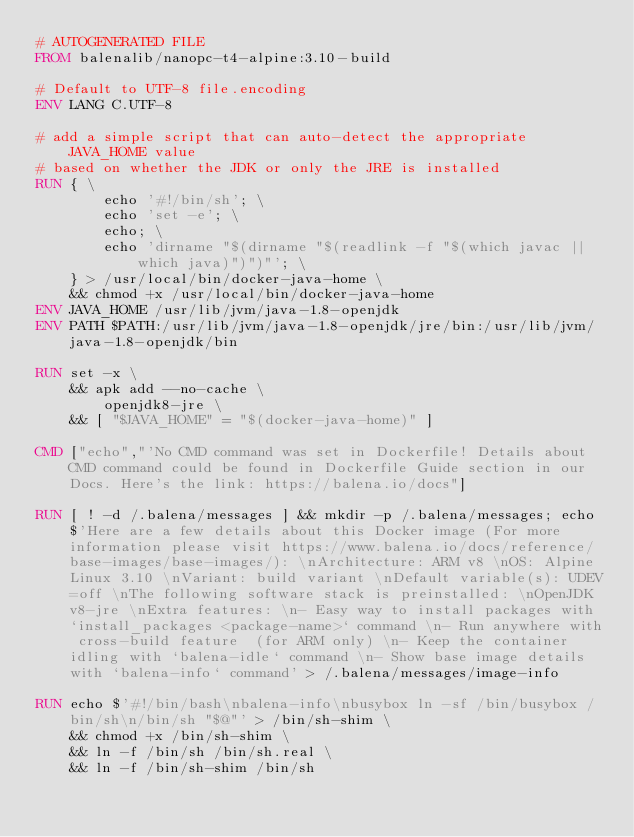Convert code to text. <code><loc_0><loc_0><loc_500><loc_500><_Dockerfile_># AUTOGENERATED FILE
FROM balenalib/nanopc-t4-alpine:3.10-build

# Default to UTF-8 file.encoding
ENV LANG C.UTF-8

# add a simple script that can auto-detect the appropriate JAVA_HOME value
# based on whether the JDK or only the JRE is installed
RUN { \
		echo '#!/bin/sh'; \
		echo 'set -e'; \
		echo; \
		echo 'dirname "$(dirname "$(readlink -f "$(which javac || which java)")")"'; \
	} > /usr/local/bin/docker-java-home \
	&& chmod +x /usr/local/bin/docker-java-home
ENV JAVA_HOME /usr/lib/jvm/java-1.8-openjdk
ENV PATH $PATH:/usr/lib/jvm/java-1.8-openjdk/jre/bin:/usr/lib/jvm/java-1.8-openjdk/bin

RUN set -x \
	&& apk add --no-cache \
		openjdk8-jre \
	&& [ "$JAVA_HOME" = "$(docker-java-home)" ]

CMD ["echo","'No CMD command was set in Dockerfile! Details about CMD command could be found in Dockerfile Guide section in our Docs. Here's the link: https://balena.io/docs"]

RUN [ ! -d /.balena/messages ] && mkdir -p /.balena/messages; echo $'Here are a few details about this Docker image (For more information please visit https://www.balena.io/docs/reference/base-images/base-images/): \nArchitecture: ARM v8 \nOS: Alpine Linux 3.10 \nVariant: build variant \nDefault variable(s): UDEV=off \nThe following software stack is preinstalled: \nOpenJDK v8-jre \nExtra features: \n- Easy way to install packages with `install_packages <package-name>` command \n- Run anywhere with cross-build feature  (for ARM only) \n- Keep the container idling with `balena-idle` command \n- Show base image details with `balena-info` command' > /.balena/messages/image-info

RUN echo $'#!/bin/bash\nbalena-info\nbusybox ln -sf /bin/busybox /bin/sh\n/bin/sh "$@"' > /bin/sh-shim \
	&& chmod +x /bin/sh-shim \
	&& ln -f /bin/sh /bin/sh.real \
	&& ln -f /bin/sh-shim /bin/sh</code> 